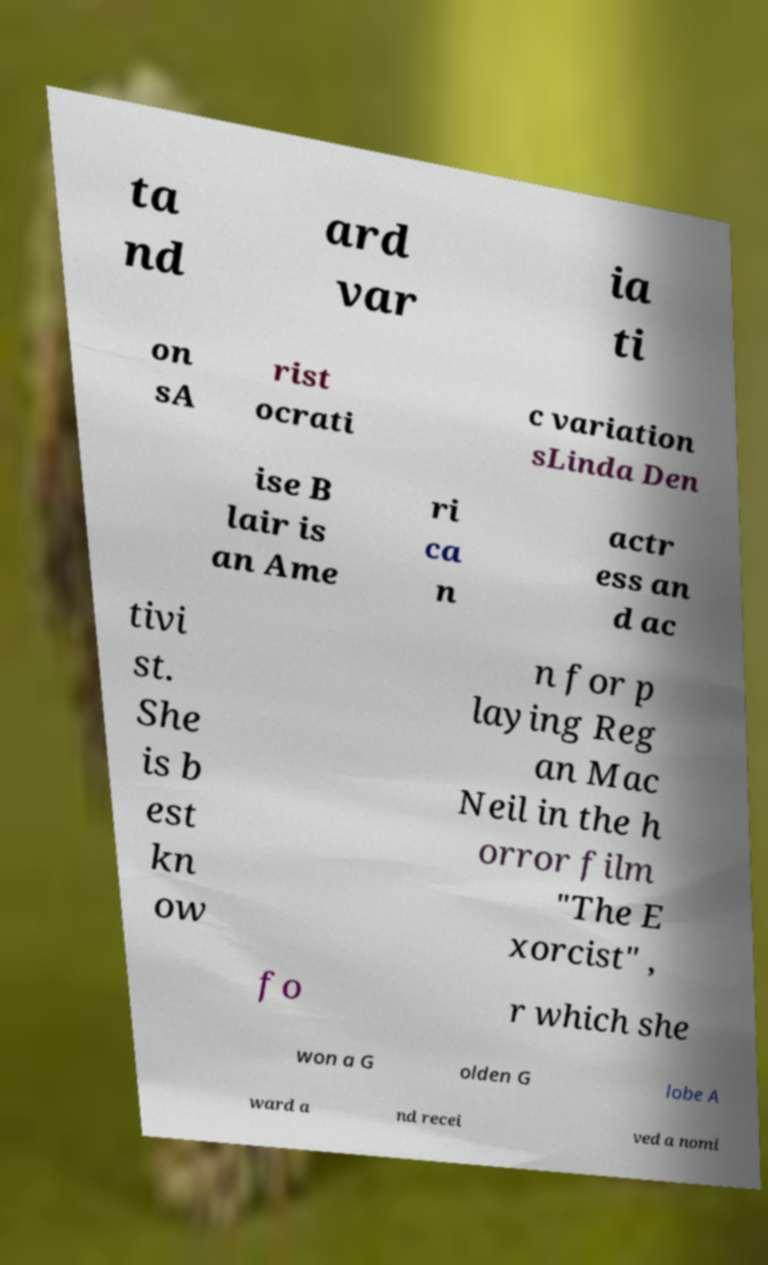I need the written content from this picture converted into text. Can you do that? ta nd ard var ia ti on sA rist ocrati c variation sLinda Den ise B lair is an Ame ri ca n actr ess an d ac tivi st. She is b est kn ow n for p laying Reg an Mac Neil in the h orror film "The E xorcist" , fo r which she won a G olden G lobe A ward a nd recei ved a nomi 